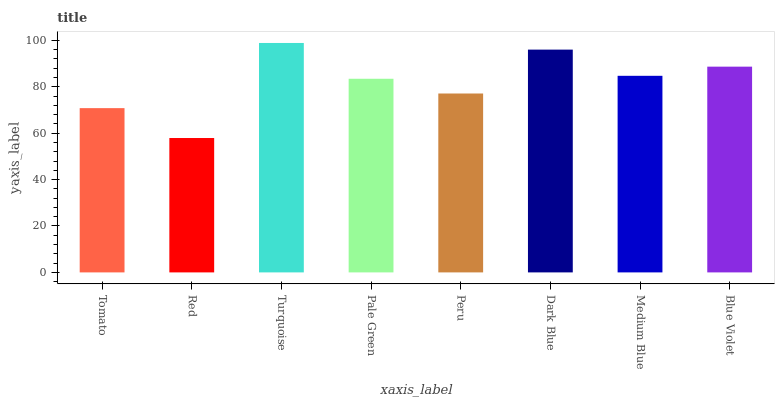Is Red the minimum?
Answer yes or no. Yes. Is Turquoise the maximum?
Answer yes or no. Yes. Is Turquoise the minimum?
Answer yes or no. No. Is Red the maximum?
Answer yes or no. No. Is Turquoise greater than Red?
Answer yes or no. Yes. Is Red less than Turquoise?
Answer yes or no. Yes. Is Red greater than Turquoise?
Answer yes or no. No. Is Turquoise less than Red?
Answer yes or no. No. Is Medium Blue the high median?
Answer yes or no. Yes. Is Pale Green the low median?
Answer yes or no. Yes. Is Blue Violet the high median?
Answer yes or no. No. Is Peru the low median?
Answer yes or no. No. 